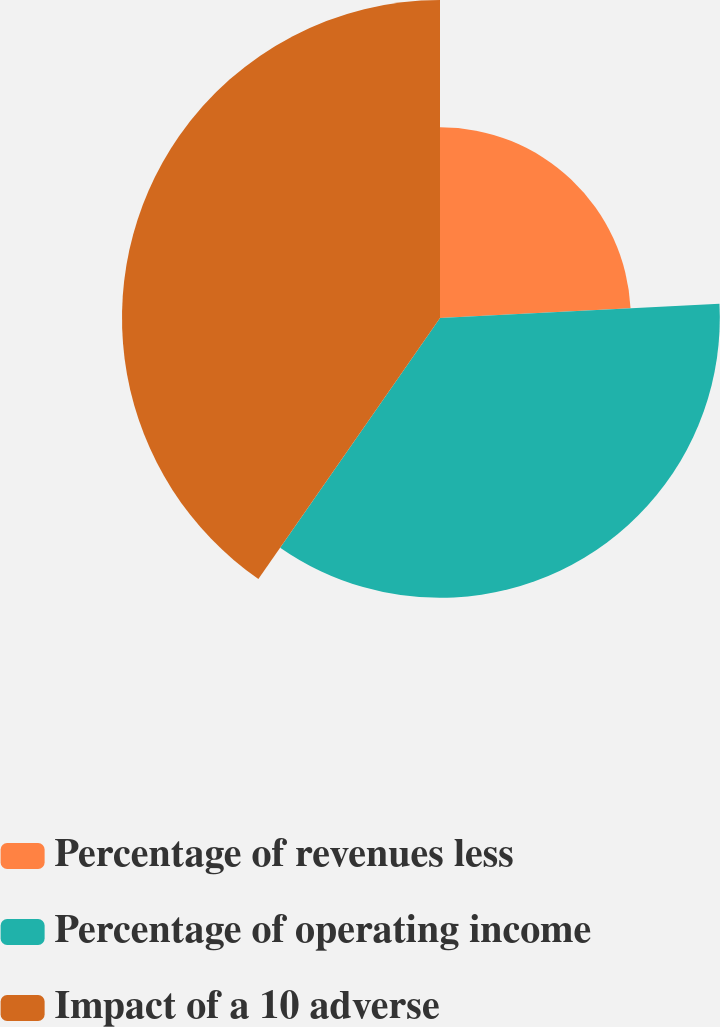Convert chart. <chart><loc_0><loc_0><loc_500><loc_500><pie_chart><fcel>Percentage of revenues less<fcel>Percentage of operating income<fcel>Impact of a 10 adverse<nl><fcel>24.19%<fcel>35.48%<fcel>40.32%<nl></chart> 